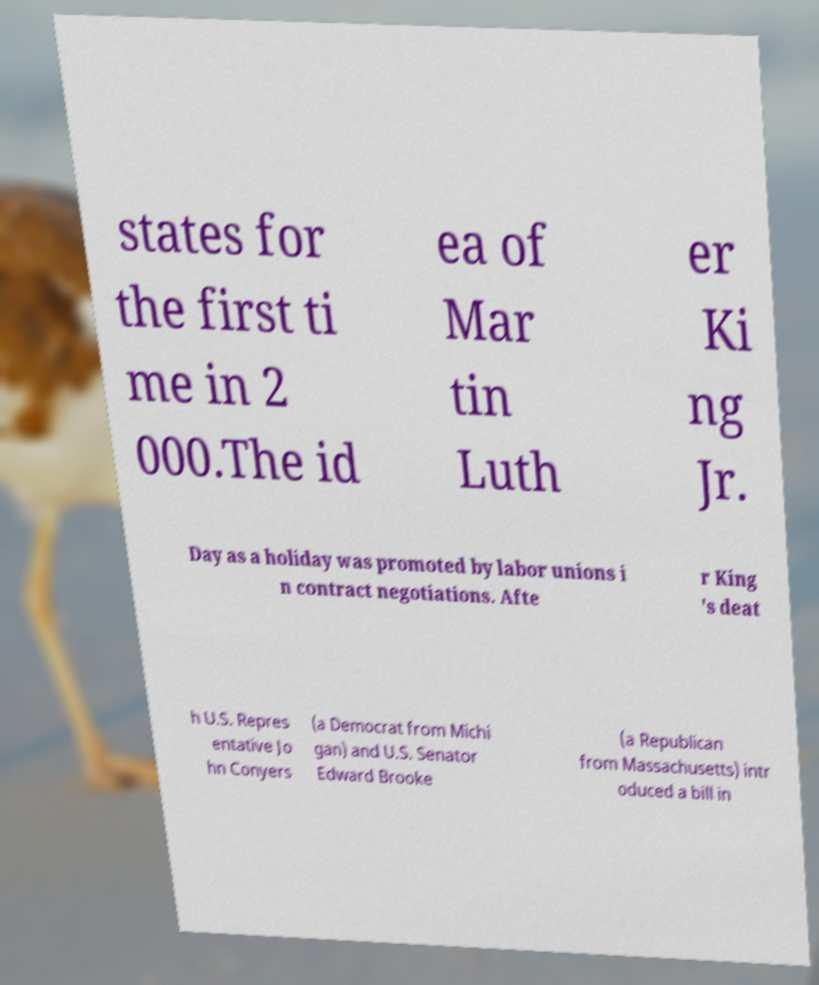I need the written content from this picture converted into text. Can you do that? states for the first ti me in 2 000.The id ea of Mar tin Luth er Ki ng Jr. Day as a holiday was promoted by labor unions i n contract negotiations. Afte r King 's deat h U.S. Repres entative Jo hn Conyers (a Democrat from Michi gan) and U.S. Senator Edward Brooke (a Republican from Massachusetts) intr oduced a bill in 